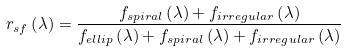Convert formula to latex. <formula><loc_0><loc_0><loc_500><loc_500>r _ { s f } \left ( \lambda \right ) = \frac { f _ { s p i r a l } \left ( \lambda \right ) + f _ { i r r e g u l a r } \left ( \lambda \right ) } { f _ { e l l i p } \left ( \lambda \right ) + f _ { s p i r a l } \left ( \lambda \right ) + f _ { i r r e g u l a r } \left ( \lambda \right ) }</formula> 